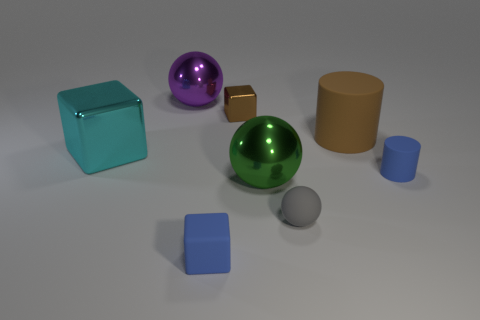Do the purple ball and the gray thing that is in front of the tiny brown metal block have the same size?
Make the answer very short. No. Are there more gray metallic cylinders than green balls?
Your answer should be compact. No. Are the cylinder behind the tiny cylinder and the large object in front of the cyan metallic object made of the same material?
Your response must be concise. No. What is the big cyan cube made of?
Make the answer very short. Metal. Are there more large metallic balls in front of the brown rubber object than yellow blocks?
Your answer should be very brief. Yes. How many small brown metallic objects are right of the thing to the left of the ball that is to the left of the tiny blue rubber block?
Keep it short and to the point. 1. There is a thing that is on the left side of the tiny brown metallic object and behind the big brown matte cylinder; what material is it made of?
Your answer should be very brief. Metal. The big rubber cylinder has what color?
Offer a terse response. Brown. Is the number of shiny balls that are to the left of the large block greater than the number of small gray matte spheres behind the big green metallic thing?
Ensure brevity in your answer.  No. There is a cylinder behind the small cylinder; what is its color?
Your response must be concise. Brown. 